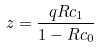Convert formula to latex. <formula><loc_0><loc_0><loc_500><loc_500>z = \frac { q R c _ { 1 } } { 1 - R c _ { 0 } }</formula> 